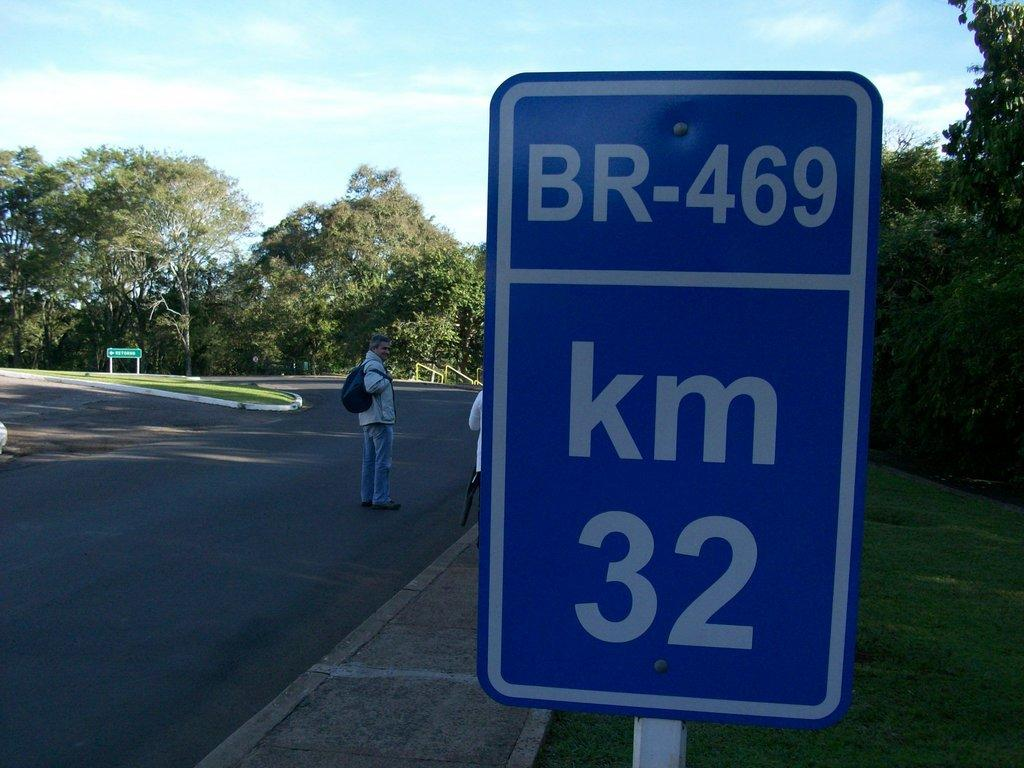<image>
Describe the image concisely. people standing on the street and a km br 469 street sign 